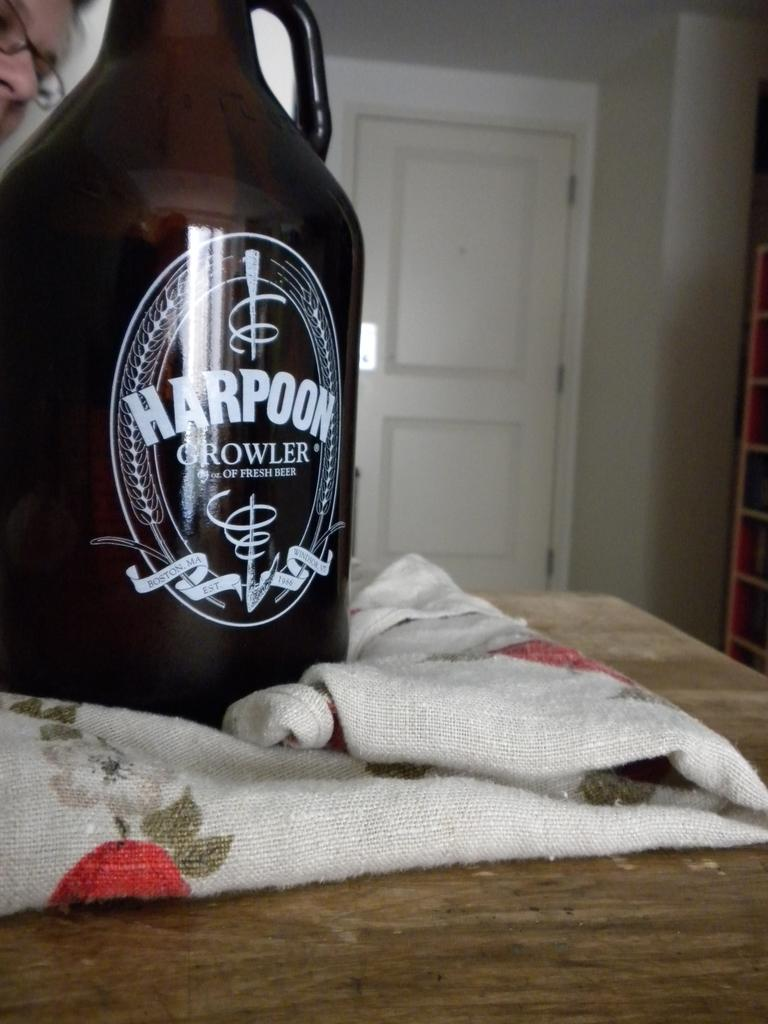<image>
Offer a succinct explanation of the picture presented. A bottle of Harpoon beer sits on a piece of fabric. 